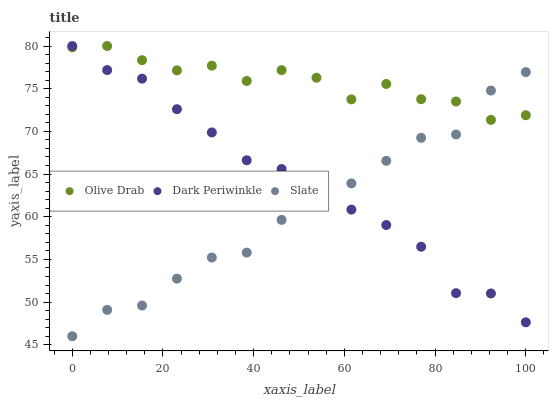Does Slate have the minimum area under the curve?
Answer yes or no. Yes. Does Olive Drab have the maximum area under the curve?
Answer yes or no. Yes. Does Dark Periwinkle have the minimum area under the curve?
Answer yes or no. No. Does Dark Periwinkle have the maximum area under the curve?
Answer yes or no. No. Is Slate the smoothest?
Answer yes or no. Yes. Is Dark Periwinkle the roughest?
Answer yes or no. Yes. Is Olive Drab the smoothest?
Answer yes or no. No. Is Olive Drab the roughest?
Answer yes or no. No. Does Slate have the lowest value?
Answer yes or no. Yes. Does Dark Periwinkle have the lowest value?
Answer yes or no. No. Does Olive Drab have the highest value?
Answer yes or no. Yes. Does Slate intersect Dark Periwinkle?
Answer yes or no. Yes. Is Slate less than Dark Periwinkle?
Answer yes or no. No. Is Slate greater than Dark Periwinkle?
Answer yes or no. No. 